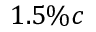Convert formula to latex. <formula><loc_0><loc_0><loc_500><loc_500>1 . 5 \% c</formula> 